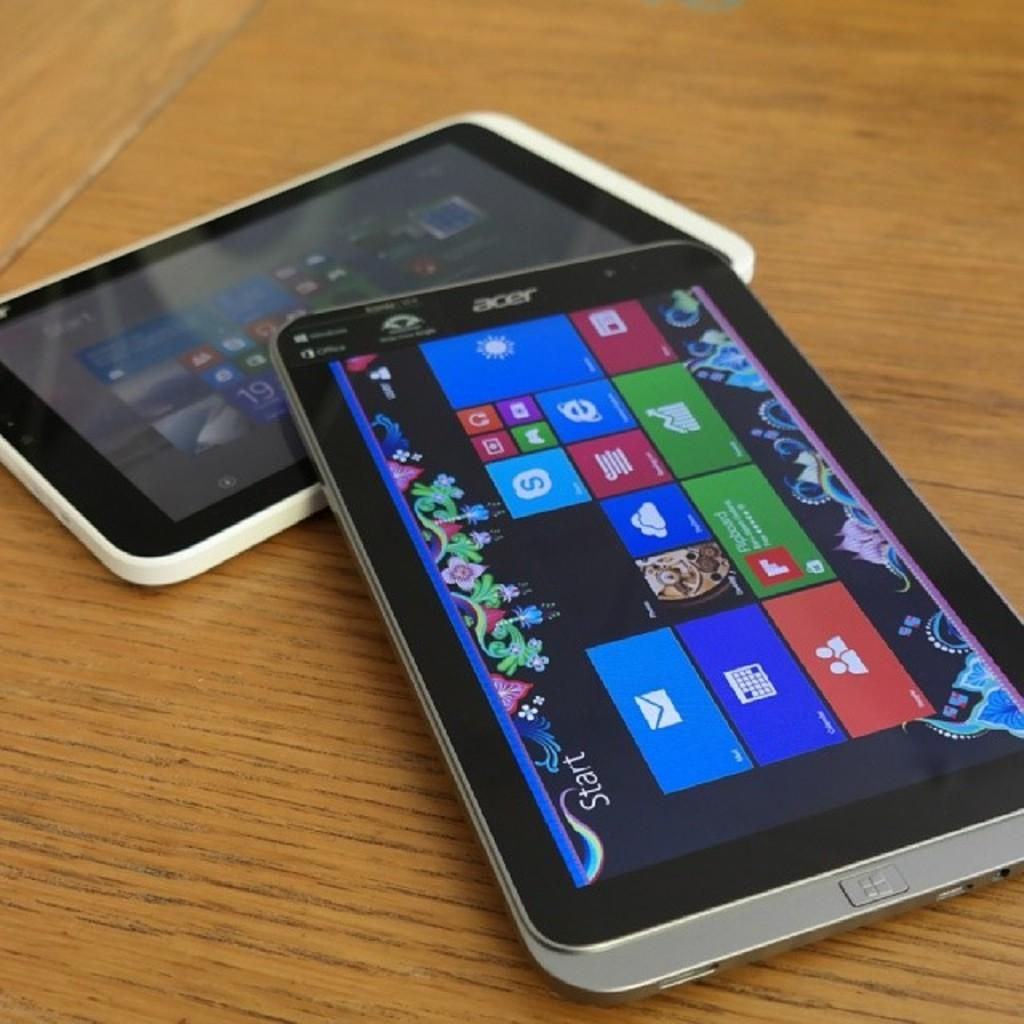What objects are present in the image? There are tablets in the image. Where are the tablets located? The tablets are on a table. What material is the table made of? The table is made of wood. Can you see any quills or quicksand in the image? No, there are no quills or quicksand present in the image. How many girls are visible in the image? There is no mention of girls in the provided facts, so we cannot determine their presence in the image. 